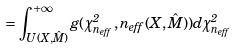<formula> <loc_0><loc_0><loc_500><loc_500>= \int _ { U ( X , \hat { M } ) } ^ { + \infty } g ( \chi ^ { 2 } _ { n _ { e f f } } , n _ { e f f } ( X , \hat { M } ) ) d \chi ^ { 2 } _ { n _ { e f f } }</formula> 